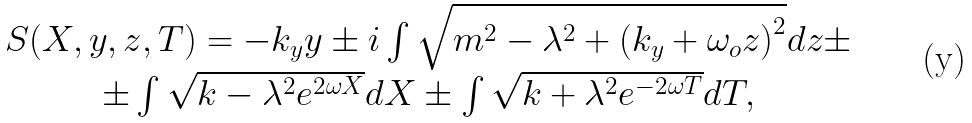<formula> <loc_0><loc_0><loc_500><loc_500>\begin{array} { c } S ( X , y , z , T ) = - k _ { y } y \pm i \int \sqrt { m ^ { 2 } - \lambda ^ { 2 } + \left ( k _ { y } + \omega _ { o } z \right ) ^ { 2 } } d z \pm \\ \pm \int \sqrt { k - \lambda ^ { 2 } e ^ { 2 \omega X } } d X \pm \int \sqrt { k + \lambda ^ { 2 } e ^ { - 2 \omega T } } d T , \end{array}</formula> 